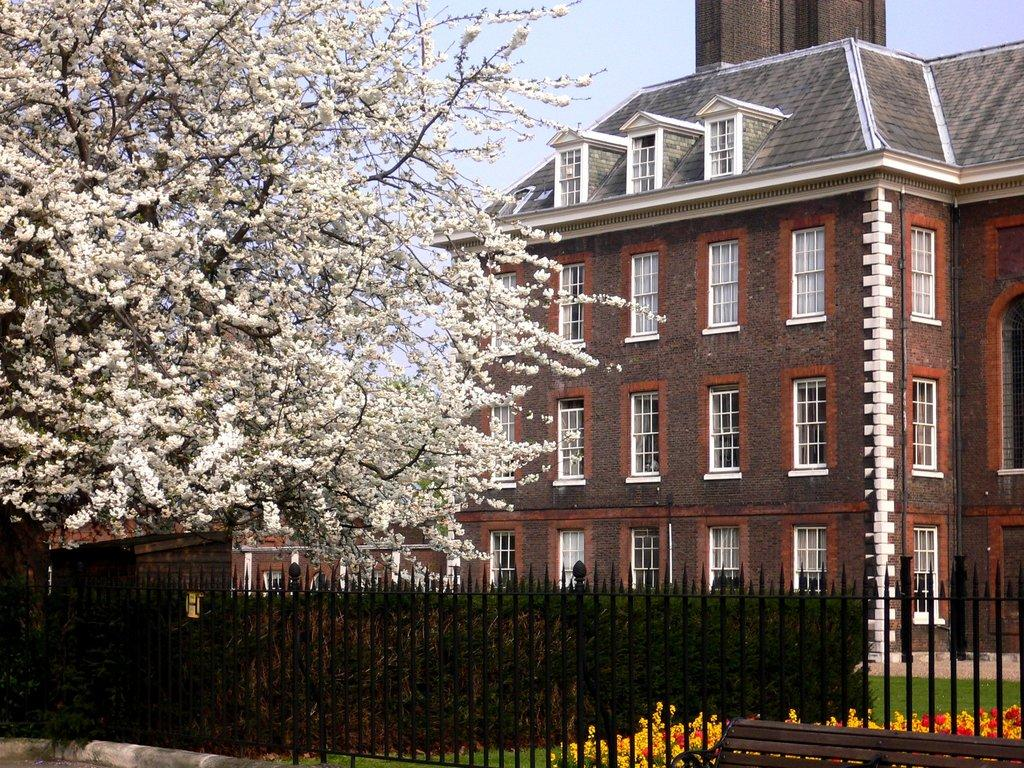What type of structure is visible in the image? There is a building in the image. What can be seen on the tree in the image? There are flowers on a tree in the image. What type of fencing is present in the image? There is an iron fencing in the image. What type of vegetation is present in the image? There are flowers on plants in the image. How does the digestion process work for the flowers in the image? The image does not depict a digestion process, as it is a static representation of a building, flowers, and fencing. 